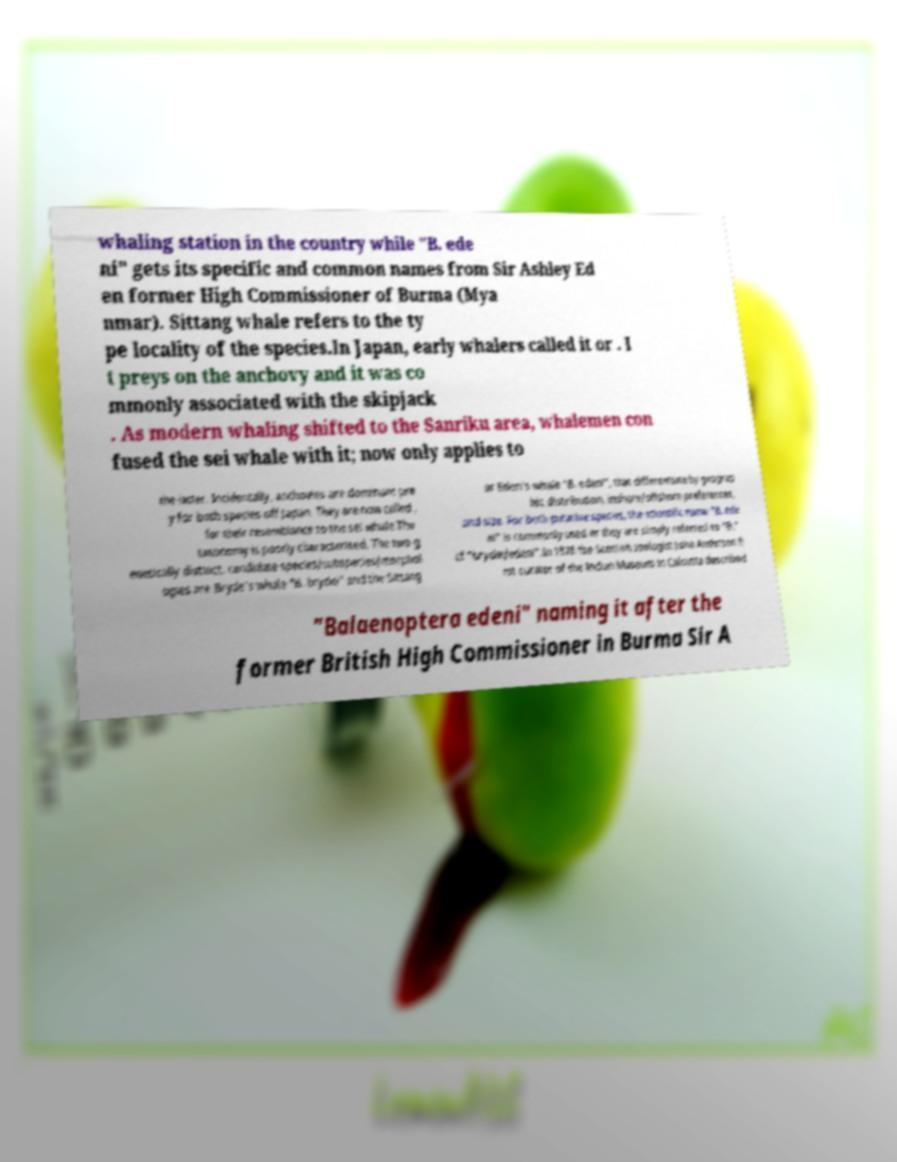Could you extract and type out the text from this image? whaling station in the country while "B. ede ni" gets its specific and common names from Sir Ashley Ed en former High Commissioner of Burma (Mya nmar). Sittang whale refers to the ty pe locality of the species.In Japan, early whalers called it or . I t preys on the anchovy and it was co mmonly associated with the skipjack . As modern whaling shifted to the Sanriku area, whalemen con fused the sei whale with it; now only applies to the latter. Incidentally, anchovies are dominant pre y for both species off Japan. They are now called , for their resemblance to the sei whale.The taxonomy is poorly characterised. The two g enetically distinct, candidate species/subspecies/morphol ogies are Bryde's whale "B. brydei" and the Sittang or Eden's whale "B. edeni", that differentiate by geograp hic distribution, inshore/offshore preferences, and size. For both putative species, the scientific name "B. ede ni" is commonly used or they are simply referred to "B." cf "brydei/edeni".In 1878 the Scottish zoologist John Anderson fi rst curator of the Indian Museum in Calcutta described "Balaenoptera edeni" naming it after the former British High Commissioner in Burma Sir A 